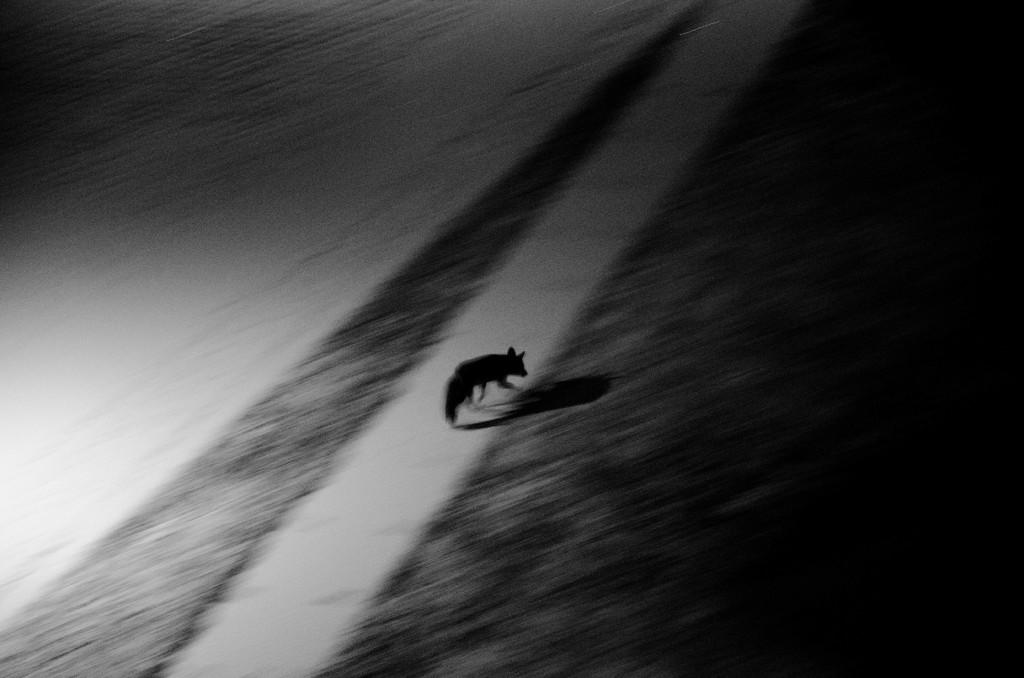What is the color scheme of the image? The image is black and white. What type of living creature is present in the image? There is an animal in the image. Where is the animal located in the image? The animal is on the ground. What type of square object can be seen in the image? There is no square object present in the image. What tool is the animal using to hammer in the image? There is no hammer or any tool usage depicted in the image. 